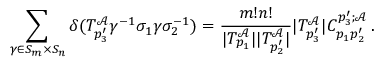Convert formula to latex. <formula><loc_0><loc_0><loc_500><loc_500>\sum _ { \gamma \in S _ { m } \times S _ { n } } \delta ( T _ { p _ { 3 } ^ { \prime } } ^ { \mathcal { A } } \gamma ^ { - 1 } \sigma _ { 1 } \gamma \sigma _ { 2 } ^ { - 1 } ) = \frac { m ! n ! } { | T _ { p _ { 1 } } ^ { \mathcal { A } } | | T _ { p _ { 2 } ^ { \prime } } ^ { \mathcal { A } } | } | T _ { p _ { 3 } ^ { \prime } } ^ { \mathcal { A } } | C _ { p _ { 1 } p _ { 2 } ^ { \prime } } ^ { p _ { 3 } ^ { \prime } ; \mathcal { A } } \, .</formula> 